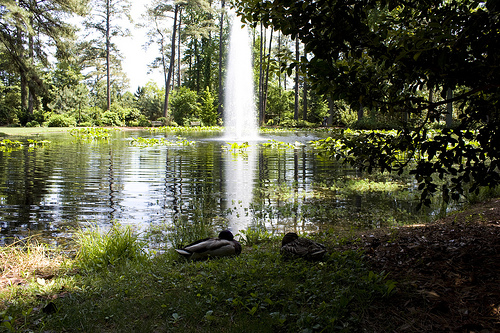<image>
Can you confirm if the duck is in the lake? No. The duck is not contained within the lake. These objects have a different spatial relationship. 